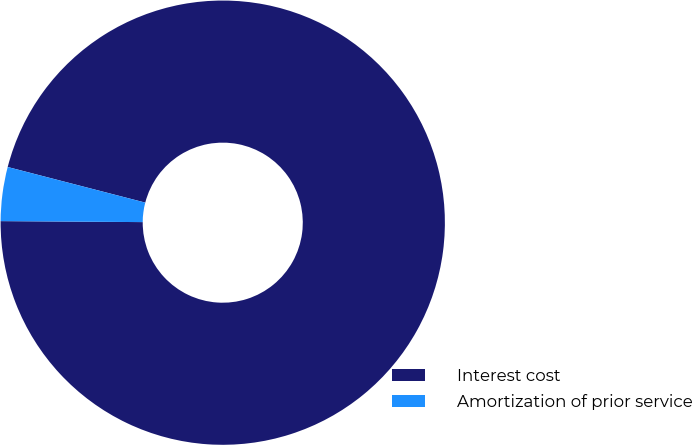Convert chart to OTSL. <chart><loc_0><loc_0><loc_500><loc_500><pie_chart><fcel>Interest cost<fcel>Amortization of prior service<nl><fcel>96.08%<fcel>3.92%<nl></chart> 